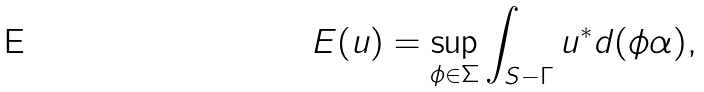Convert formula to latex. <formula><loc_0><loc_0><loc_500><loc_500>E ( u ) = \sup _ { \phi \in \Sigma } \int _ { S - \Gamma } u ^ { * } d ( \phi \alpha ) ,</formula> 